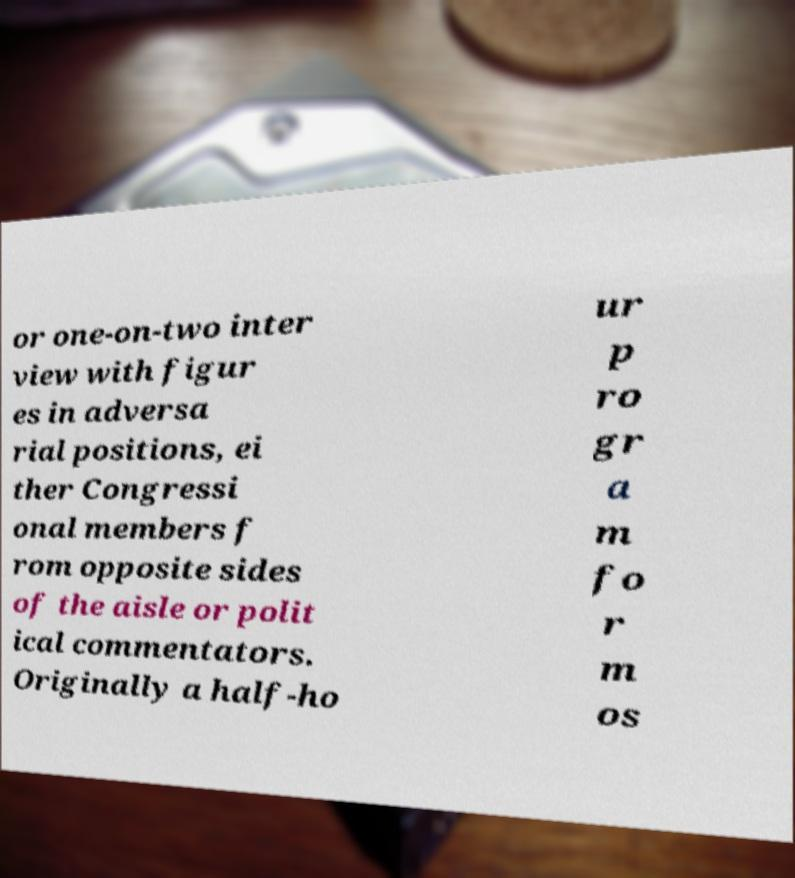Please identify and transcribe the text found in this image. or one-on-two inter view with figur es in adversa rial positions, ei ther Congressi onal members f rom opposite sides of the aisle or polit ical commentators. Originally a half-ho ur p ro gr a m fo r m os 